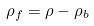<formula> <loc_0><loc_0><loc_500><loc_500>\rho _ { f } = \rho - \rho _ { b }</formula> 